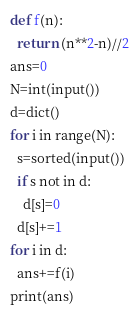Convert code to text. <code><loc_0><loc_0><loc_500><loc_500><_Python_>def f(n):
  return (n**2-n)//2
ans=0
N=int(input())
d=dict()
for i in range(N):
  s=sorted(input())
  if s not in d:
    d[s]=0
  d[s]+=1
for i in d:
  ans+=f(i)
print(ans)</code> 